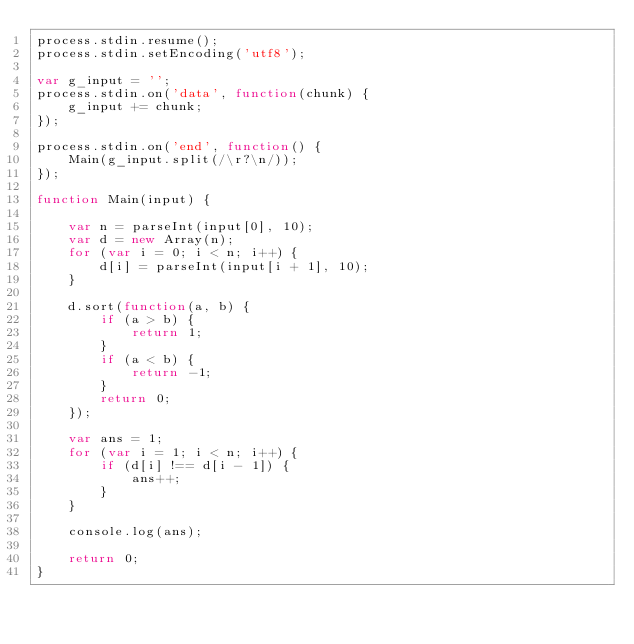Convert code to text. <code><loc_0><loc_0><loc_500><loc_500><_JavaScript_>process.stdin.resume();
process.stdin.setEncoding('utf8');

var g_input = '';
process.stdin.on('data', function(chunk) {
    g_input += chunk;
});

process.stdin.on('end', function() {
    Main(g_input.split(/\r?\n/));
});

function Main(input) {

    var n = parseInt(input[0], 10);
    var d = new Array(n);
    for (var i = 0; i < n; i++) {
        d[i] = parseInt(input[i + 1], 10);
    }

    d.sort(function(a, b) {
        if (a > b) {
            return 1;
        }
        if (a < b) {
            return -1;
        }
        return 0;
    });

    var ans = 1;
    for (var i = 1; i < n; i++) {
        if (d[i] !== d[i - 1]) {
            ans++;
        }
    }

    console.log(ans);

    return 0;
}
</code> 